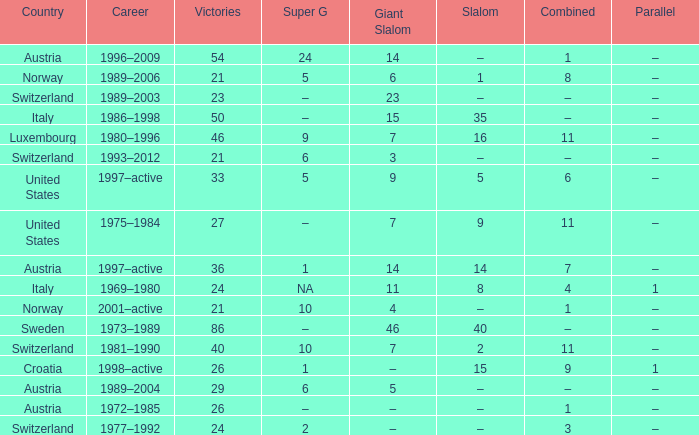What Giant Slalom has Victories larger than 27, a Slalom of –, and a Career of 1996–2009? 14.0. Would you be able to parse every entry in this table? {'header': ['Country', 'Career', 'Victories', 'Super G', 'Giant Slalom', 'Slalom', 'Combined', 'Parallel'], 'rows': [['Austria', '1996–2009', '54', '24', '14', '–', '1', '–'], ['Norway', '1989–2006', '21', '5', '6', '1', '8', '–'], ['Switzerland', '1989–2003', '23', '–', '23', '–', '–', '–'], ['Italy', '1986–1998', '50', '–', '15', '35', '–', '–'], ['Luxembourg', '1980–1996', '46', '9', '7', '16', '11', '–'], ['Switzerland', '1993–2012', '21', '6', '3', '–', '–', '–'], ['United States', '1997–active', '33', '5', '9', '5', '6', '–'], ['United States', '1975–1984', '27', '–', '7', '9', '11', '–'], ['Austria', '1997–active', '36', '1', '14', '14', '7', '–'], ['Italy', '1969–1980', '24', 'NA', '11', '8', '4', '1'], ['Norway', '2001–active', '21', '10', '4', '–', '1', '–'], ['Sweden', '1973–1989', '86', '–', '46', '40', '–', '–'], ['Switzerland', '1981–1990', '40', '10', '7', '2', '11', '–'], ['Croatia', '1998–active', '26', '1', '–', '15', '9', '1'], ['Austria', '1989–2004', '29', '6', '5', '–', '–', '–'], ['Austria', '1972–1985', '26', '–', '–', '–', '1', '–'], ['Switzerland', '1977–1992', '24', '2', '–', '–', '3', '–']]} 